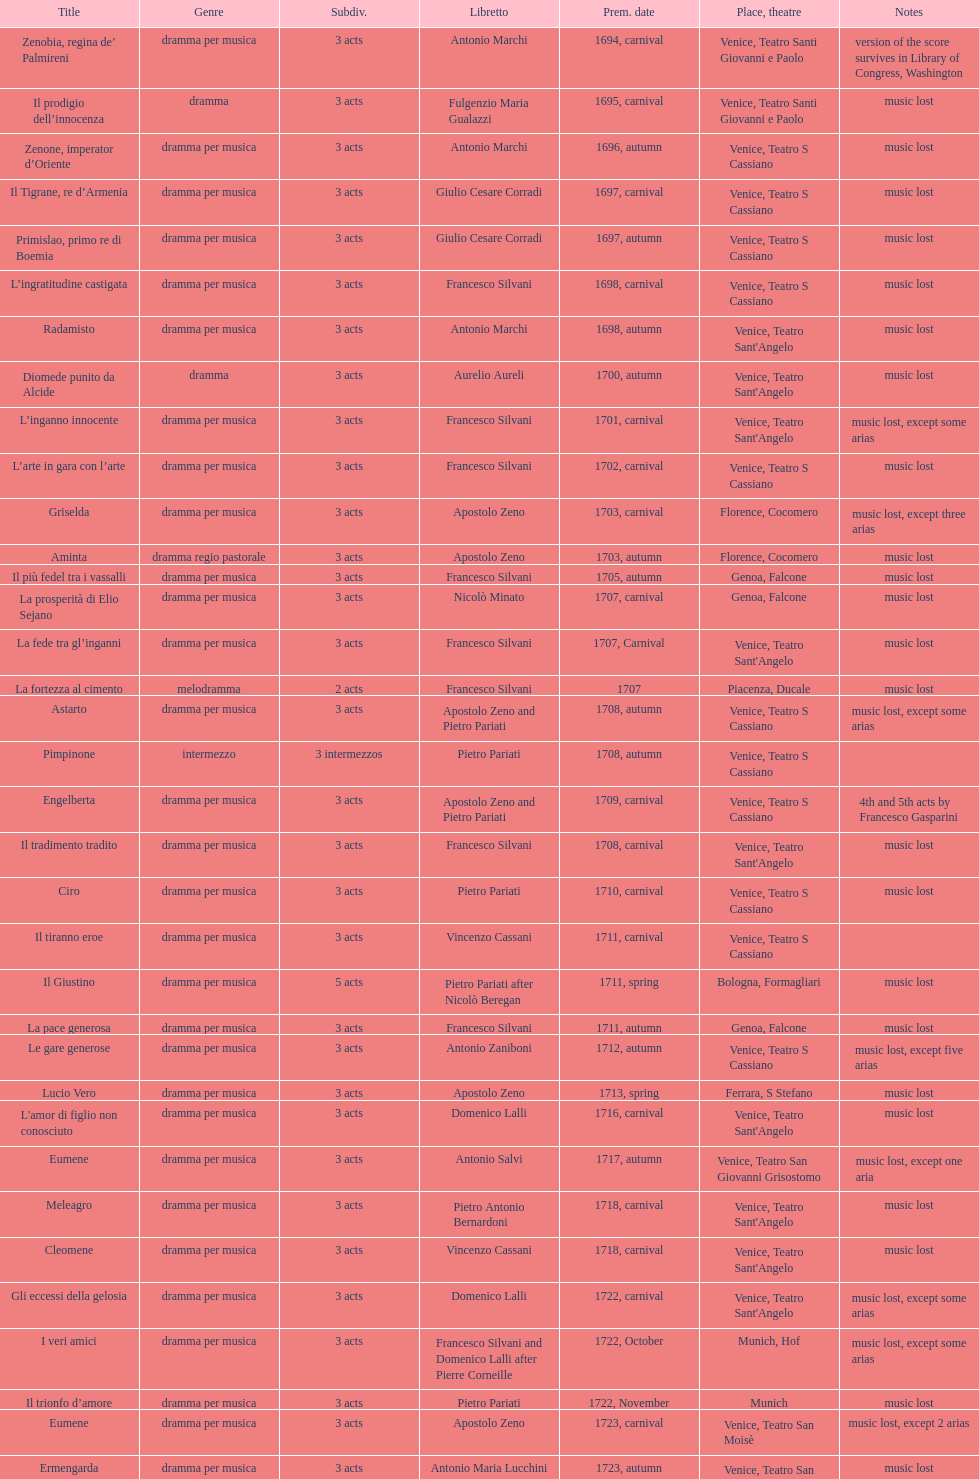Which opera has at least 5 acts? Il Giustino. Could you parse the entire table? {'header': ['Title', 'Genre', 'Subdiv.', 'Libretto', 'Prem. date', 'Place, theatre', 'Notes'], 'rows': [['Zenobia, regina de’ Palmireni', 'dramma per musica', '3 acts', 'Antonio Marchi', '1694, carnival', 'Venice, Teatro Santi Giovanni e Paolo', 'version of the score survives in Library of Congress, Washington'], ['Il prodigio dell’innocenza', 'dramma', '3 acts', 'Fulgenzio Maria Gualazzi', '1695, carnival', 'Venice, Teatro Santi Giovanni e Paolo', 'music lost'], ['Zenone, imperator d’Oriente', 'dramma per musica', '3 acts', 'Antonio Marchi', '1696, autumn', 'Venice, Teatro S Cassiano', 'music lost'], ['Il Tigrane, re d’Armenia', 'dramma per musica', '3 acts', 'Giulio Cesare Corradi', '1697, carnival', 'Venice, Teatro S Cassiano', 'music lost'], ['Primislao, primo re di Boemia', 'dramma per musica', '3 acts', 'Giulio Cesare Corradi', '1697, autumn', 'Venice, Teatro S Cassiano', 'music lost'], ['L’ingratitudine castigata', 'dramma per musica', '3 acts', 'Francesco Silvani', '1698, carnival', 'Venice, Teatro S Cassiano', 'music lost'], ['Radamisto', 'dramma per musica', '3 acts', 'Antonio Marchi', '1698, autumn', "Venice, Teatro Sant'Angelo", 'music lost'], ['Diomede punito da Alcide', 'dramma', '3 acts', 'Aurelio Aureli', '1700, autumn', "Venice, Teatro Sant'Angelo", 'music lost'], ['L’inganno innocente', 'dramma per musica', '3 acts', 'Francesco Silvani', '1701, carnival', "Venice, Teatro Sant'Angelo", 'music lost, except some arias'], ['L’arte in gara con l’arte', 'dramma per musica', '3 acts', 'Francesco Silvani', '1702, carnival', 'Venice, Teatro S Cassiano', 'music lost'], ['Griselda', 'dramma per musica', '3 acts', 'Apostolo Zeno', '1703, carnival', 'Florence, Cocomero', 'music lost, except three arias'], ['Aminta', 'dramma regio pastorale', '3 acts', 'Apostolo Zeno', '1703, autumn', 'Florence, Cocomero', 'music lost'], ['Il più fedel tra i vassalli', 'dramma per musica', '3 acts', 'Francesco Silvani', '1705, autumn', 'Genoa, Falcone', 'music lost'], ['La prosperità di Elio Sejano', 'dramma per musica', '3 acts', 'Nicolò Minato', '1707, carnival', 'Genoa, Falcone', 'music lost'], ['La fede tra gl’inganni', 'dramma per musica', '3 acts', 'Francesco Silvani', '1707, Carnival', "Venice, Teatro Sant'Angelo", 'music lost'], ['La fortezza al cimento', 'melodramma', '2 acts', 'Francesco Silvani', '1707', 'Piacenza, Ducale', 'music lost'], ['Astarto', 'dramma per musica', '3 acts', 'Apostolo Zeno and Pietro Pariati', '1708, autumn', 'Venice, Teatro S Cassiano', 'music lost, except some arias'], ['Pimpinone', 'intermezzo', '3 intermezzos', 'Pietro Pariati', '1708, autumn', 'Venice, Teatro S Cassiano', ''], ['Engelberta', 'dramma per musica', '3 acts', 'Apostolo Zeno and Pietro Pariati', '1709, carnival', 'Venice, Teatro S Cassiano', '4th and 5th acts by Francesco Gasparini'], ['Il tradimento tradito', 'dramma per musica', '3 acts', 'Francesco Silvani', '1708, carnival', "Venice, Teatro Sant'Angelo", 'music lost'], ['Ciro', 'dramma per musica', '3 acts', 'Pietro Pariati', '1710, carnival', 'Venice, Teatro S Cassiano', 'music lost'], ['Il tiranno eroe', 'dramma per musica', '3 acts', 'Vincenzo Cassani', '1711, carnival', 'Venice, Teatro S Cassiano', ''], ['Il Giustino', 'dramma per musica', '5 acts', 'Pietro Pariati after Nicolò Beregan', '1711, spring', 'Bologna, Formagliari', 'music lost'], ['La pace generosa', 'dramma per musica', '3 acts', 'Francesco Silvani', '1711, autumn', 'Genoa, Falcone', 'music lost'], ['Le gare generose', 'dramma per musica', '3 acts', 'Antonio Zaniboni', '1712, autumn', 'Venice, Teatro S Cassiano', 'music lost, except five arias'], ['Lucio Vero', 'dramma per musica', '3 acts', 'Apostolo Zeno', '1713, spring', 'Ferrara, S Stefano', 'music lost'], ["L'amor di figlio non conosciuto", 'dramma per musica', '3 acts', 'Domenico Lalli', '1716, carnival', "Venice, Teatro Sant'Angelo", 'music lost'], ['Eumene', 'dramma per musica', '3 acts', 'Antonio Salvi', '1717, autumn', 'Venice, Teatro San Giovanni Grisostomo', 'music lost, except one aria'], ['Meleagro', 'dramma per musica', '3 acts', 'Pietro Antonio Bernardoni', '1718, carnival', "Venice, Teatro Sant'Angelo", 'music lost'], ['Cleomene', 'dramma per musica', '3 acts', 'Vincenzo Cassani', '1718, carnival', "Venice, Teatro Sant'Angelo", 'music lost'], ['Gli eccessi della gelosia', 'dramma per musica', '3 acts', 'Domenico Lalli', '1722, carnival', "Venice, Teatro Sant'Angelo", 'music lost, except some arias'], ['I veri amici', 'dramma per musica', '3 acts', 'Francesco Silvani and Domenico Lalli after Pierre Corneille', '1722, October', 'Munich, Hof', 'music lost, except some arias'], ['Il trionfo d’amore', 'dramma per musica', '3 acts', 'Pietro Pariati', '1722, November', 'Munich', 'music lost'], ['Eumene', 'dramma per musica', '3 acts', 'Apostolo Zeno', '1723, carnival', 'Venice, Teatro San Moisè', 'music lost, except 2 arias'], ['Ermengarda', 'dramma per musica', '3 acts', 'Antonio Maria Lucchini', '1723, autumn', 'Venice, Teatro San Moisè', 'music lost'], ['Antigono, tutore di Filippo, re di Macedonia', 'tragedia', '5 acts', 'Giovanni Piazzon', '1724, carnival', 'Venice, Teatro San Moisè', '5th act by Giovanni Porta, music lost'], ['Scipione nelle Spagne', 'dramma per musica', '3 acts', 'Apostolo Zeno', '1724, Ascension', 'Venice, Teatro San Samuele', 'music lost'], ['Laodice', 'dramma per musica', '3 acts', 'Angelo Schietti', '1724, autumn', 'Venice, Teatro San Moisè', 'music lost, except 2 arias'], ['Didone abbandonata', 'tragedia', '3 acts', 'Metastasio', '1725, carnival', 'Venice, Teatro S Cassiano', 'music lost'], ["L'impresario delle Isole Canarie", 'intermezzo', '2 acts', 'Metastasio', '1725, carnival', 'Venice, Teatro S Cassiano', 'music lost'], ['Alcina delusa da Ruggero', 'dramma per musica', '3 acts', 'Antonio Marchi', '1725, autumn', 'Venice, Teatro S Cassiano', 'music lost'], ['I rivali generosi', 'dramma per musica', '3 acts', 'Apostolo Zeno', '1725', 'Brescia, Nuovo', ''], ['La Statira', 'dramma per musica', '3 acts', 'Apostolo Zeno and Pietro Pariati', '1726, Carnival', 'Rome, Teatro Capranica', ''], ['Malsazio e Fiammetta', 'intermezzo', '', '', '1726, Carnival', 'Rome, Teatro Capranica', ''], ['Il trionfo di Armida', 'dramma per musica', '3 acts', 'Girolamo Colatelli after Torquato Tasso', '1726, autumn', 'Venice, Teatro San Moisè', 'music lost'], ['L’incostanza schernita', 'dramma comico-pastorale', '3 acts', 'Vincenzo Cassani', '1727, Ascension', 'Venice, Teatro San Samuele', 'music lost, except some arias'], ['Le due rivali in amore', 'dramma per musica', '3 acts', 'Aurelio Aureli', '1728, autumn', 'Venice, Teatro San Moisè', 'music lost'], ['Il Satrapone', 'intermezzo', '', 'Salvi', '1729', 'Parma, Omodeo', ''], ['Li stratagemmi amorosi', 'dramma per musica', '3 acts', 'F Passerini', '1730, carnival', 'Venice, Teatro San Moisè', 'music lost'], ['Elenia', 'dramma per musica', '3 acts', 'Luisa Bergalli', '1730, carnival', "Venice, Teatro Sant'Angelo", 'music lost'], ['Merope', 'dramma', '3 acts', 'Apostolo Zeno', '1731, autumn', 'Prague, Sporck Theater', 'mostly by Albinoni, music lost'], ['Il più infedel tra gli amanti', 'dramma per musica', '3 acts', 'Angelo Schietti', '1731, autumn', 'Treviso, Dolphin', 'music lost'], ['Ardelinda', 'dramma', '3 acts', 'Bartolomeo Vitturi', '1732, autumn', "Venice, Teatro Sant'Angelo", 'music lost, except five arias'], ['Candalide', 'dramma per musica', '3 acts', 'Bartolomeo Vitturi', '1734, carnival', "Venice, Teatro Sant'Angelo", 'music lost'], ['Artamene', 'dramma per musica', '3 acts', 'Bartolomeo Vitturi', '1741, carnival', "Venice, Teatro Sant'Angelo", 'music lost']]} 